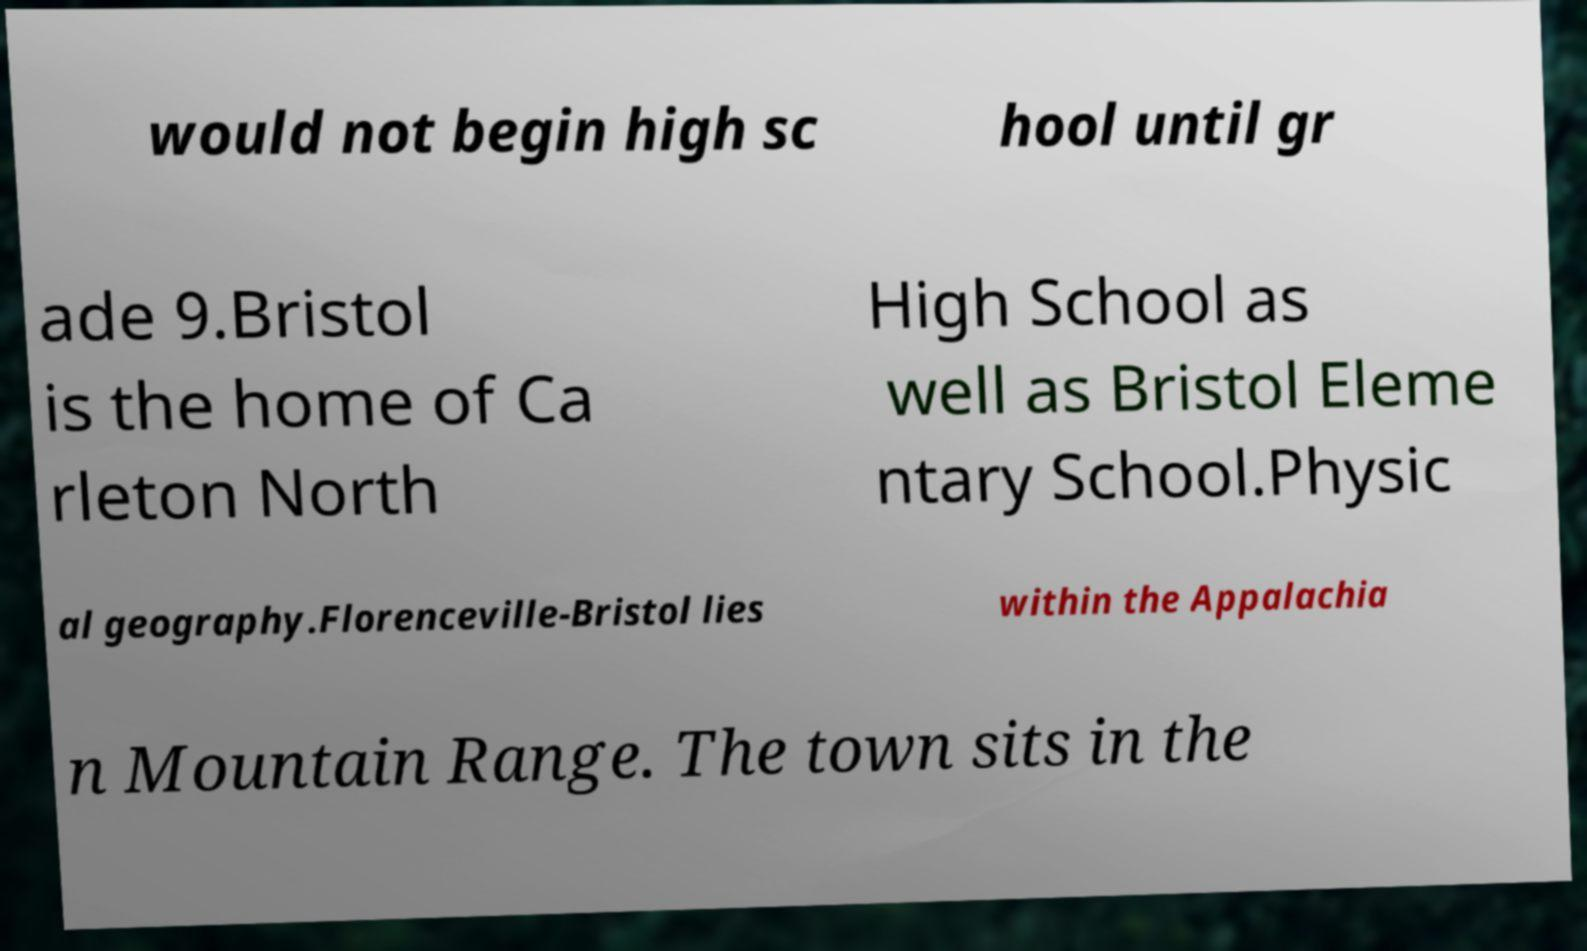Can you accurately transcribe the text from the provided image for me? would not begin high sc hool until gr ade 9.Bristol is the home of Ca rleton North High School as well as Bristol Eleme ntary School.Physic al geography.Florenceville-Bristol lies within the Appalachia n Mountain Range. The town sits in the 